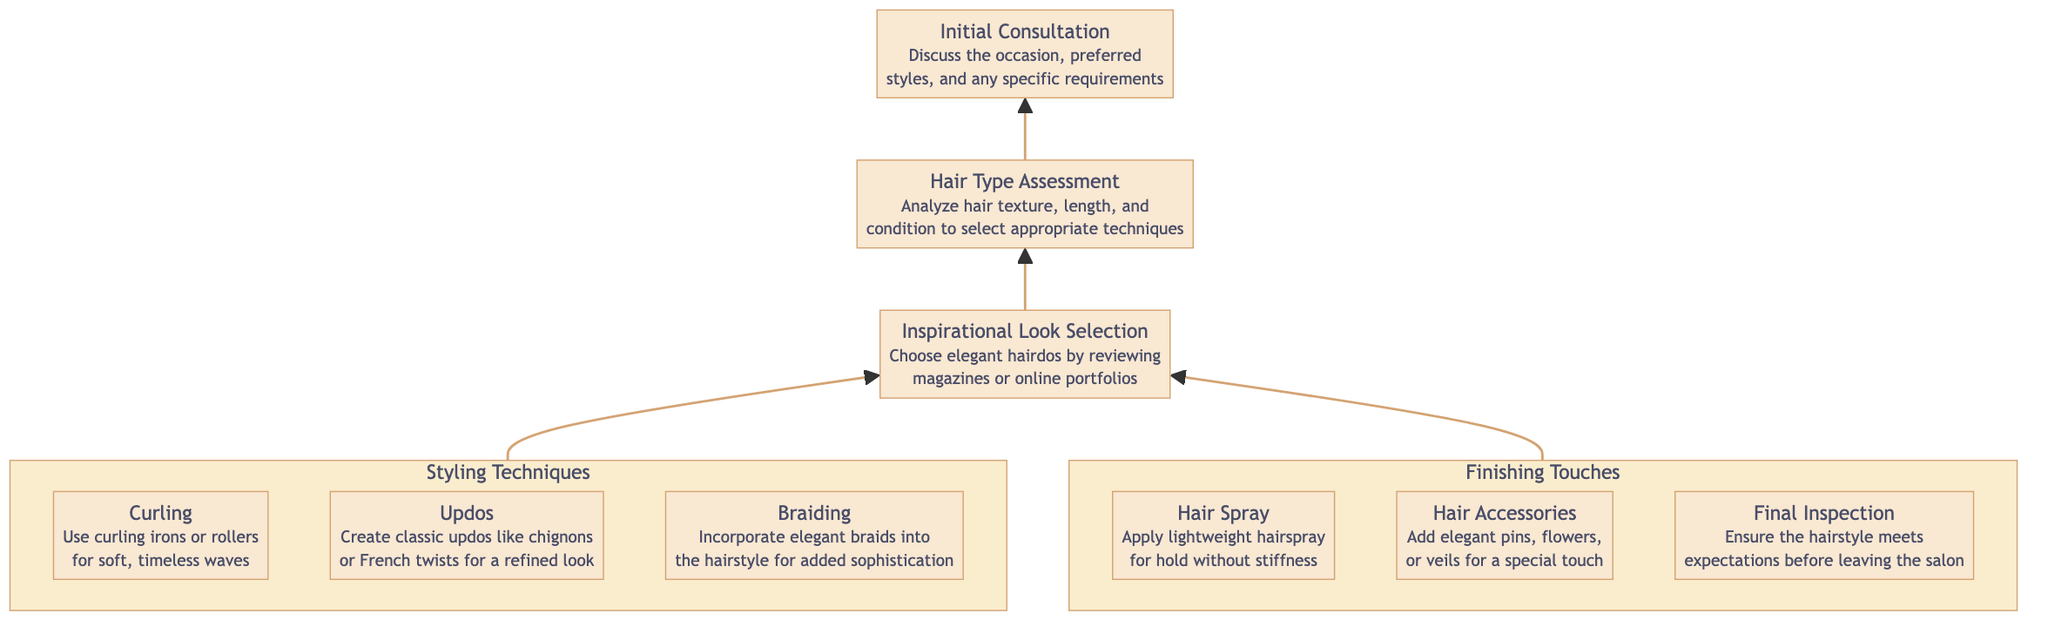What is the first step in the hair styling process? The first step in the diagram is "Initial Consultation," which is represented at the top of the flow chart.
Answer: Initial Consultation How many styling techniques are shown in the diagram? There are three styling techniques listed in the "Styling Techniques" section: Curling, Updos, and Braiding.
Answer: 3 What comes immediately after “Hair Type Assessment”? After "Hair Type Assessment", the diagram indicates "Inspirational Look Selection" as the next step in the flow.
Answer: Inspirational Look Selection Which step involves adding accessories? The "Finishing Touches" section includes "Hair Accessories," which is the step that involves adding accessories.
Answer: Hair Accessories What technique uses curling irons or rollers? The technique that uses curling irons or rollers is "Curling," as indicated in the "Styling Techniques" section.
Answer: Curling How are the "Finishing Touches" connected to the styling techniques? "Finishing Touches" comes after the "Styling Techniques" section and is linked to it as one of the completion steps required for the hairstyle.
Answer: Through flow connection What is the last step before leaving the salon? The last step before leaving the salon is "Final Inspection," which ensures the hairstyle meets expectations.
Answer: Final Inspection Which child node describes a classic updo style? The child node that describes a classic updo style is "Updos," detailing styles like chignons or French twists.
Answer: Updos What follows after selecting an inspirational look? After selecting an inspirational look, the next step is to conduct the "Hair Type Assessment" to choose suitable techniques.
Answer: Hair Type Assessment 